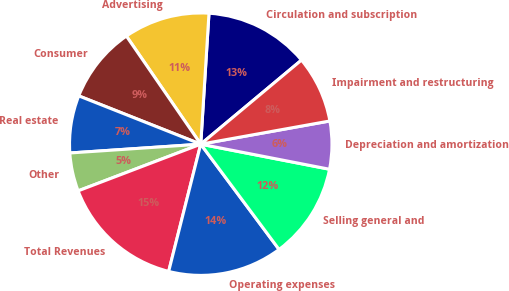Convert chart. <chart><loc_0><loc_0><loc_500><loc_500><pie_chart><fcel>Circulation and subscription<fcel>Advertising<fcel>Consumer<fcel>Real estate<fcel>Other<fcel>Total Revenues<fcel>Operating expenses<fcel>Selling general and<fcel>Depreciation and amortization<fcel>Impairment and restructuring<nl><fcel>12.93%<fcel>10.59%<fcel>9.41%<fcel>7.07%<fcel>4.72%<fcel>15.28%<fcel>14.11%<fcel>11.76%<fcel>5.89%<fcel>8.24%<nl></chart> 